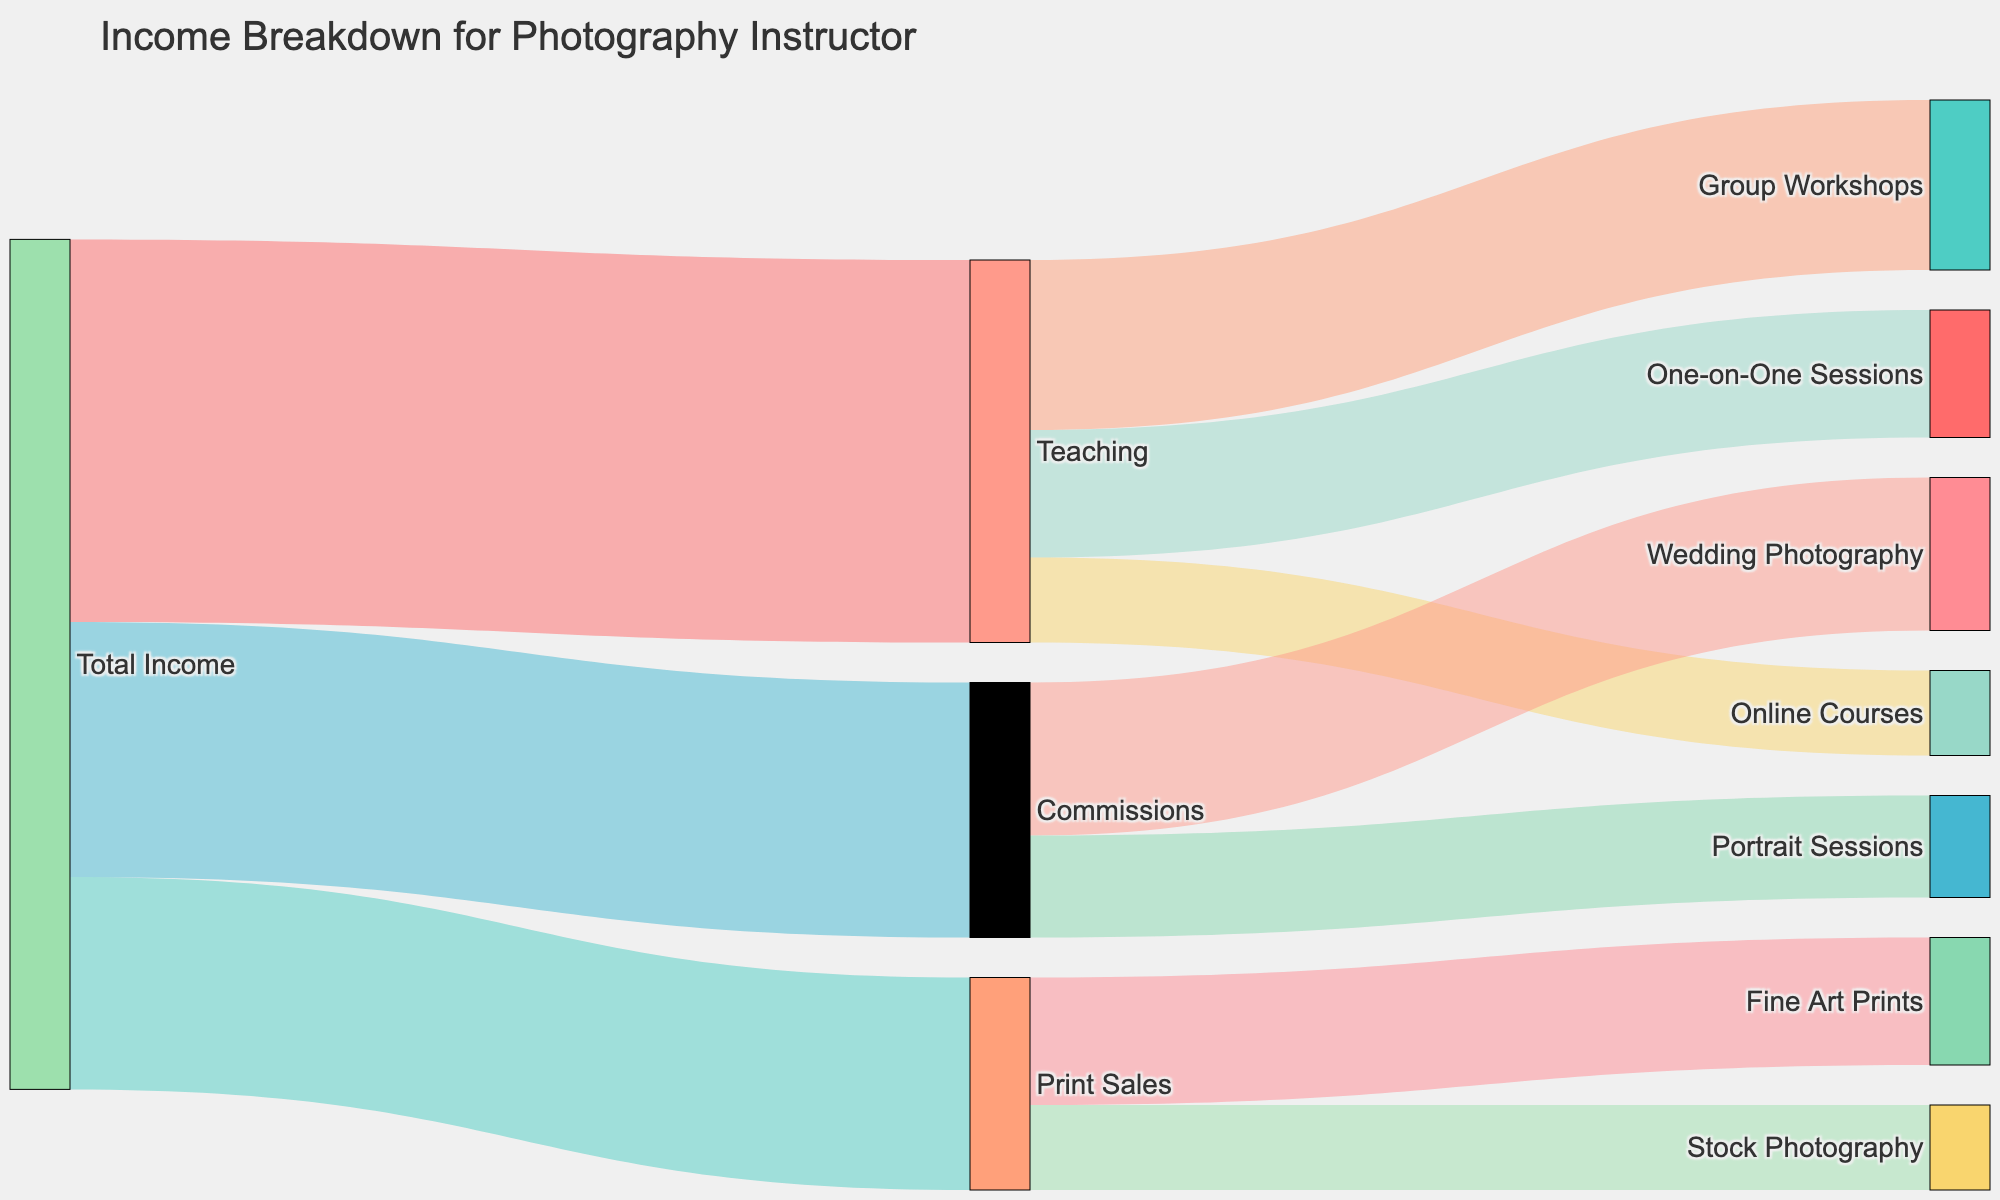What is the title of the Sankey Diagram? The title is usually found at the top of the diagram, providing a summary of what the chart represents. In this case, it reads "Income Breakdown for Photography Instructor".
Answer: "Income Breakdown for Photography Instructor" How much total income does the photography instructor earn from print sales? Locate the "Print Sales" node and trace back to "Total Income". The value shown is $25,000.
Answer: $25,000 Which income source contributes the most to the photographer's total income? Compare the three main categories: Teaching, Print Sales, and Commissions. Teaching has the highest value at $45,000.
Answer: Teaching What's the combined income from One-on-One Sessions and Online Courses? Add the values from the "One-on-One Sessions" and "Online Courses" nodes under "Teaching": $15,000 + $10,000 = $25,000.
Answer: $25,000 How much more income does the instructor make from Group Workshops compared to Stock Photography? Identify "Group Workshops" under "Teaching" and "Stock Photography" under "Print Sales". Subtract the value of Stock Photography ($10,000) from Group Workshops ($20,000): $20,000 - $10,000 = $10,000.
Answer: $10,000 Which category under Teaching generates the least income? Compare the values under "Teaching": Group Workshops ($20,000), One-on-One Sessions ($15,000), and Online Courses ($10,000). Online Courses has the least value.
Answer: Online Courses What is the total income from commissions? Trace from the "Commissions" node back to "Total Income". The value is $30,000.
Answer: $30,000 How much more does the photographer make from Wedding Photography compared to Portrait Sessions? Identify "Wedding Photography" ($18,000) and "Portrait Sessions" ($12,000) under Commissions. Subtract to find the difference: $18,000 - $12,000 = $6,000.
Answer: $6,000 Which has a higher contribution: Fine Art Prints or Stock Photography? Compare the values of "Fine Art Prints" ($15,000) and "Stock Photography" ($10,000). Fine Art Prints has a higher value.
Answer: Fine Art Prints 